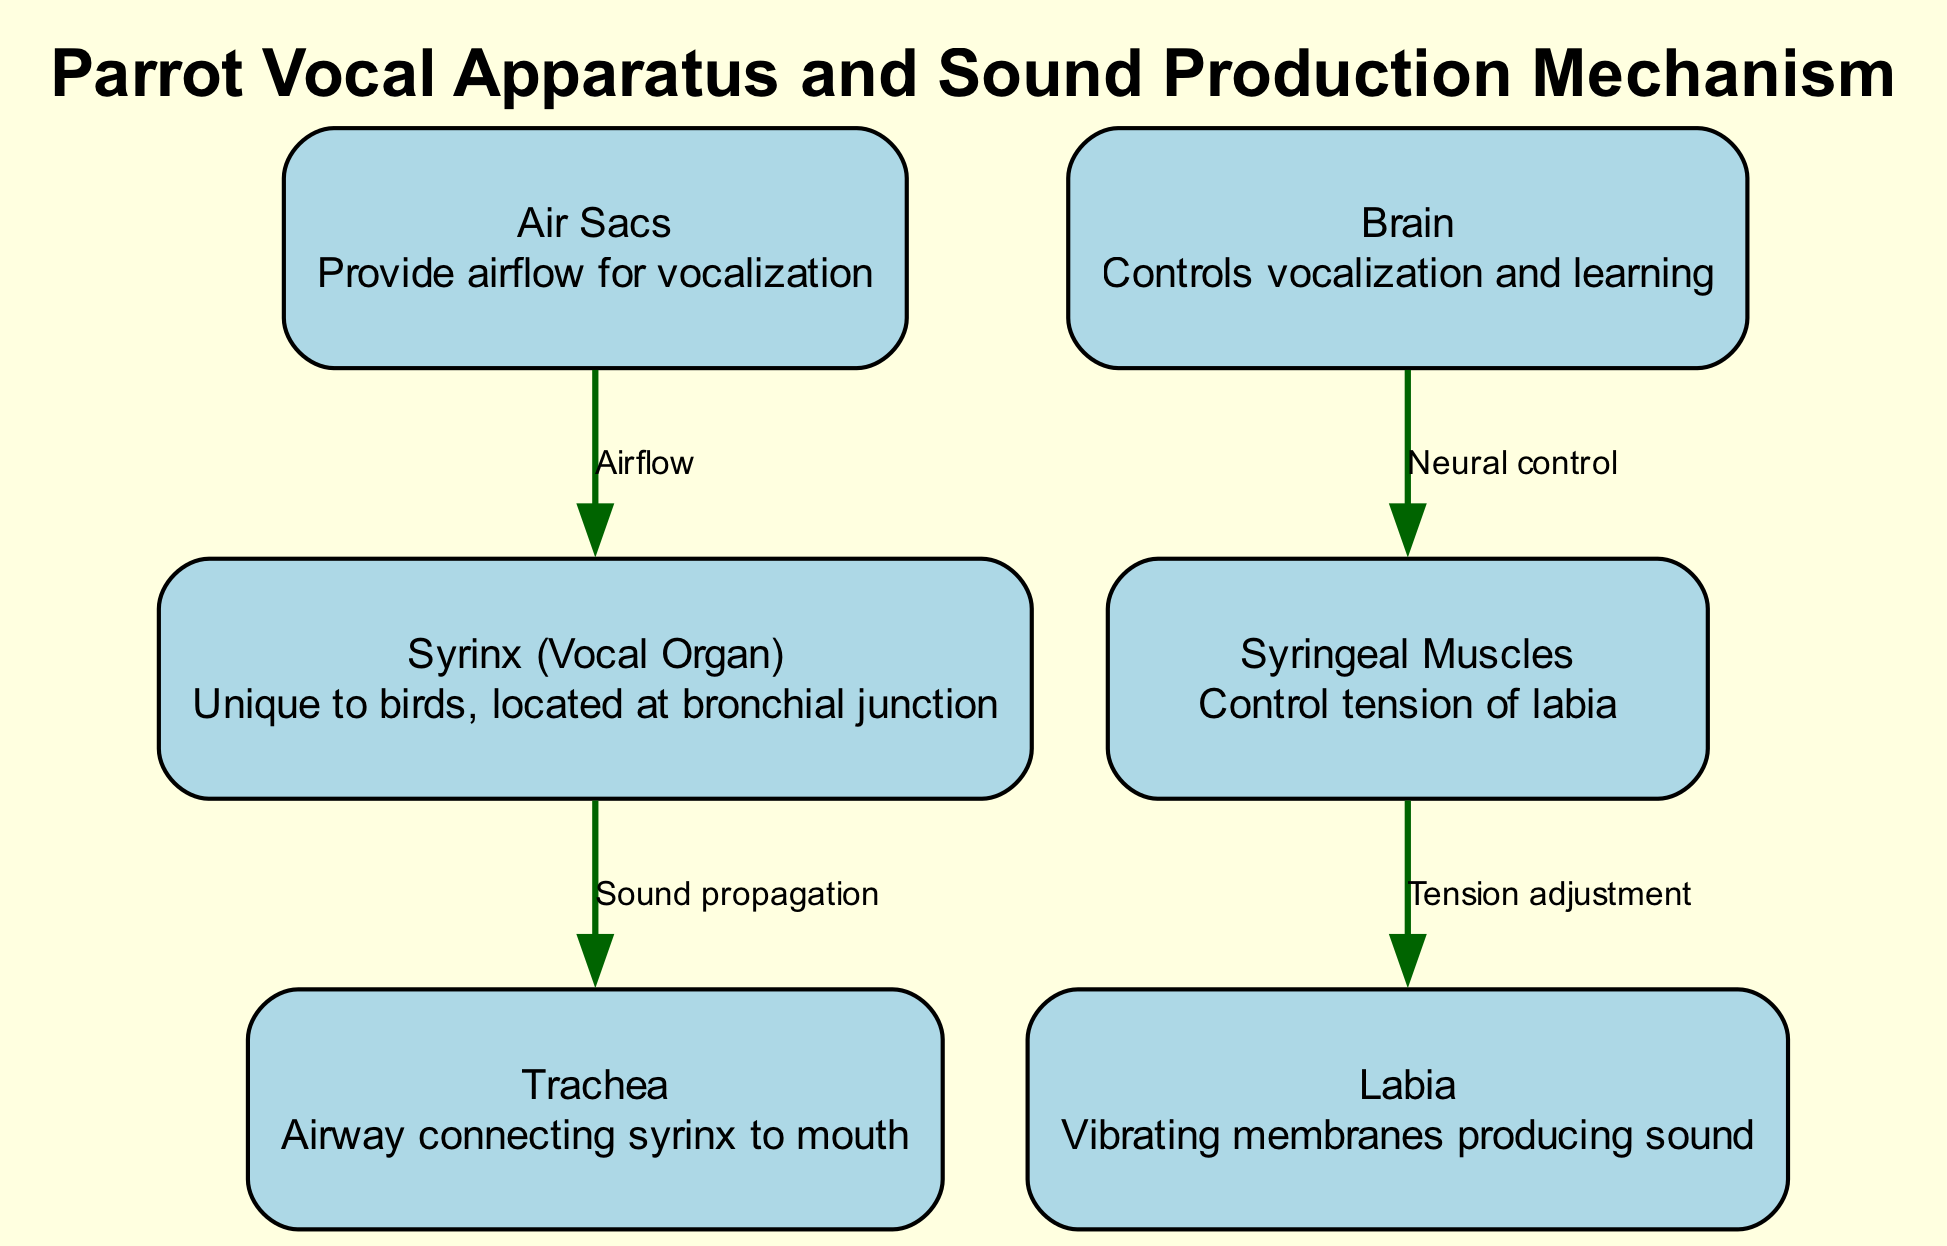What is the vocal organ unique to birds? The diagram identifies the "Syrinx" as the vocal organ, emphasizing its uniqueness to birds and indicating its location at the bronchial junction.
Answer: Syrinx How many nodes are in the diagram? By counting the listed nodes, we find there are six distinct nodes representing different components of the parrot's vocal apparatus.
Answer: 6 What role do the syrinx muscles play? The diagram states that the "Syringeal Muscles" control the tension of the labia, crucial for sound production.
Answer: Tension adjustment Which component provides airflow for vocalization? From the diagram, "Air Sacs" are identified as the component responsible for providing airflow necessary for vocalization.
Answer: Air Sacs What connects the syrinx to the mouth? The diagram depicts the "Trachea" as the airway that connects the syrinx to the mouth, illustrating its role in sound propagation.
Answer: Trachea What is controlled by the brain in the vocal apparatus? The diagram indicates that the brain is responsible for controlling vocalization and the learning aspect of it, which is crucial for a parrot's ability to mimic sounds.
Answer: Vocalization and learning What directly influences the labia during sound production? According to the diagram, the "Syringeal Muscles" directly influence the labia by adjusting their tension, which is essential for creating different sounds.
Answer: Tension adjustment How does air travel from the air sacs to the syrinx? The flow of air from the air sacs to the syrinx is depicted with an edge labeled "Airflow", indicating a direct relationship that facilitates sound production.
Answer: Airflow What component is responsible for sound propagation from the syrinx? The diagram specifies that the "Trachea" is responsible for sound propagation once the sound is produced in the syrinx, connecting it to the vocal output.
Answer: Trachea 